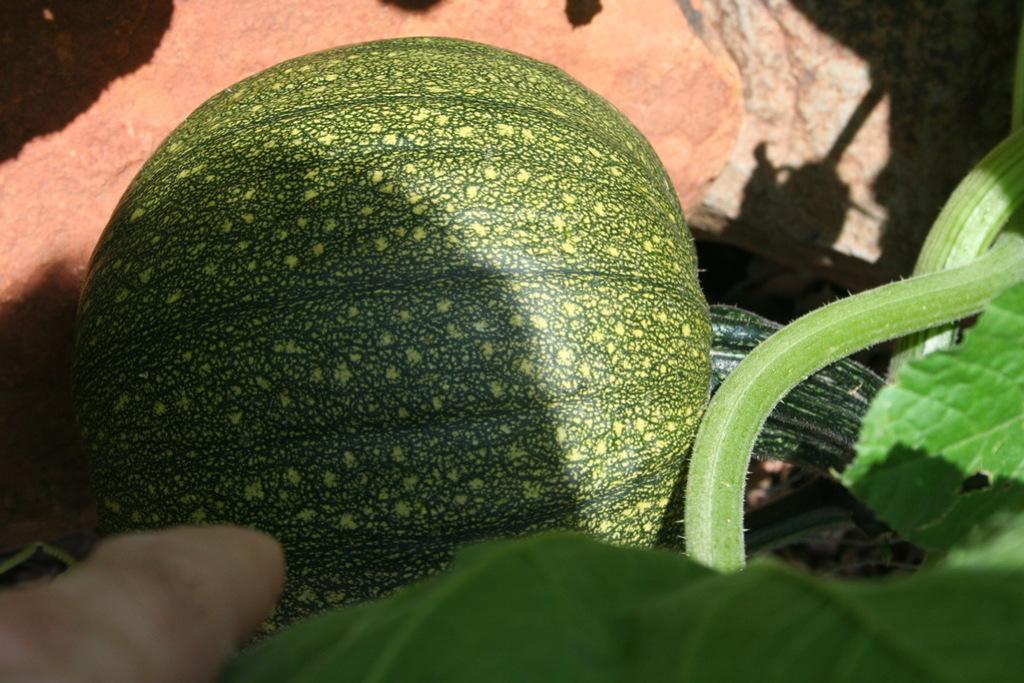How would you summarize this image in a sentence or two? In this image we can see a fruit to the plant. In the background we can see the ground. 